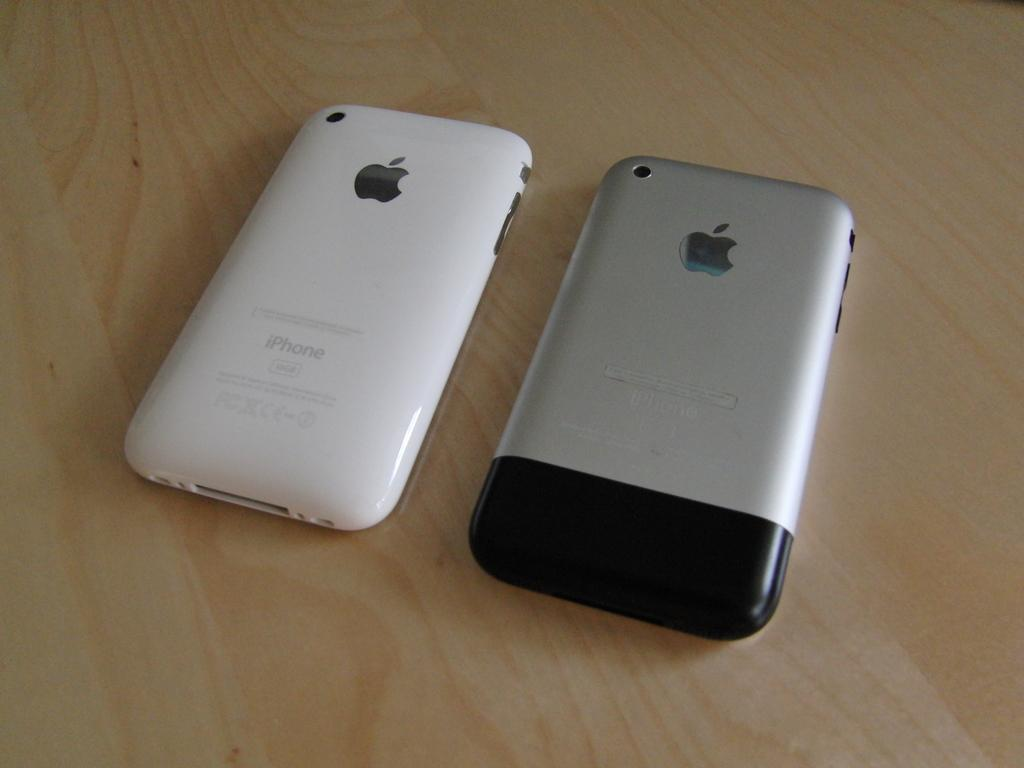<image>
Offer a succinct explanation of the picture presented. Two iPhones, one white and one silver are placed face down on a wooden surface. 